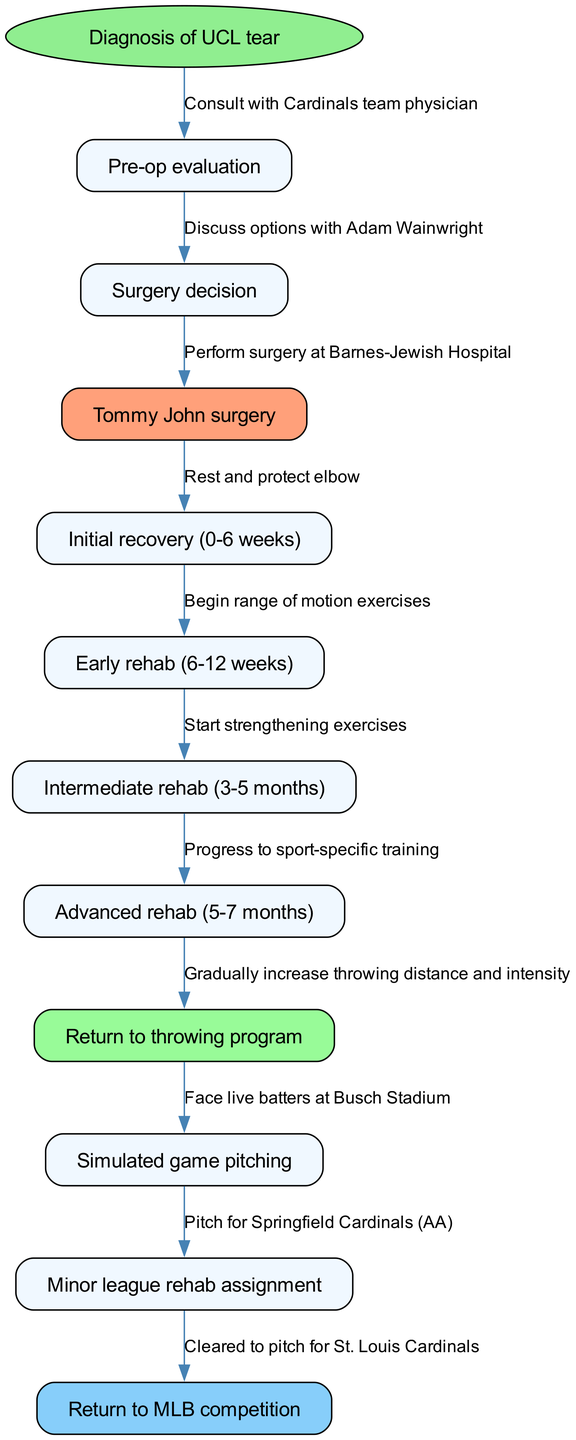What is the starting point of the pathway? The starting point, as indicated in the diagram, is "Diagnosis of UCL tear". This is the first node from which all other nodes follow in the clinical pathway.
Answer: Diagnosis of UCL tear How many nodes are there in total? Counting the start point and each of the 11 nodes listed in the diagram, there are a total of 12 nodes (1 start point + 11 nodes).
Answer: 12 What is the node immediately after "Surgery decision"? The node that follows "Surgery decision" is "Tommy John surgery", as per the flow established in the diagram.
Answer: Tommy John surgery What is the color of the node representing initial recovery? The node for "Initial recovery (0-6 weeks)" is styled normally with a light blue color, rather than a highlighted color, which indicates it's part of the regular sequence and not a milestone.
Answer: Light blue Which node follows "Return to throwing program"? The node that comes next after "Return to throwing program" is "Simulated game pitching" according to the sequential flow shown in the diagram.
Answer: Simulated game pitching What is the final milestone in the pathway? The final milestone in the pathway is "Return to MLB competition", which is the last node that the rehabilitation process leads to.
Answer: Return to MLB competition How many weeks does the initial recovery phase last? The initial recovery phase lasts for 6 weeks, as indicated by the label on the corresponding node in the diagram.
Answer: 6 weeks Which step involves facing live batters? The step where a pitcher faces live batters is labeled as "Face live batters at Busch Stadium", and it occurs after progressing through the throwing program.
Answer: Face live batters at Busch Stadium What is the significance of the node colored in light green? The node colored in light green represents "Return to throwing program," signifying a key milestone where the athlete begins a controlled throwing regimen after surgery.
Answer: Return to throwing program What is the relationship between "Early rehab" and "Surgery decision"? "Early rehab" occurs after "Tommy John surgery" which directly follows the "Surgery decision,” creating a linear relationship in the clinical pathway.
Answer: Linear relationship 